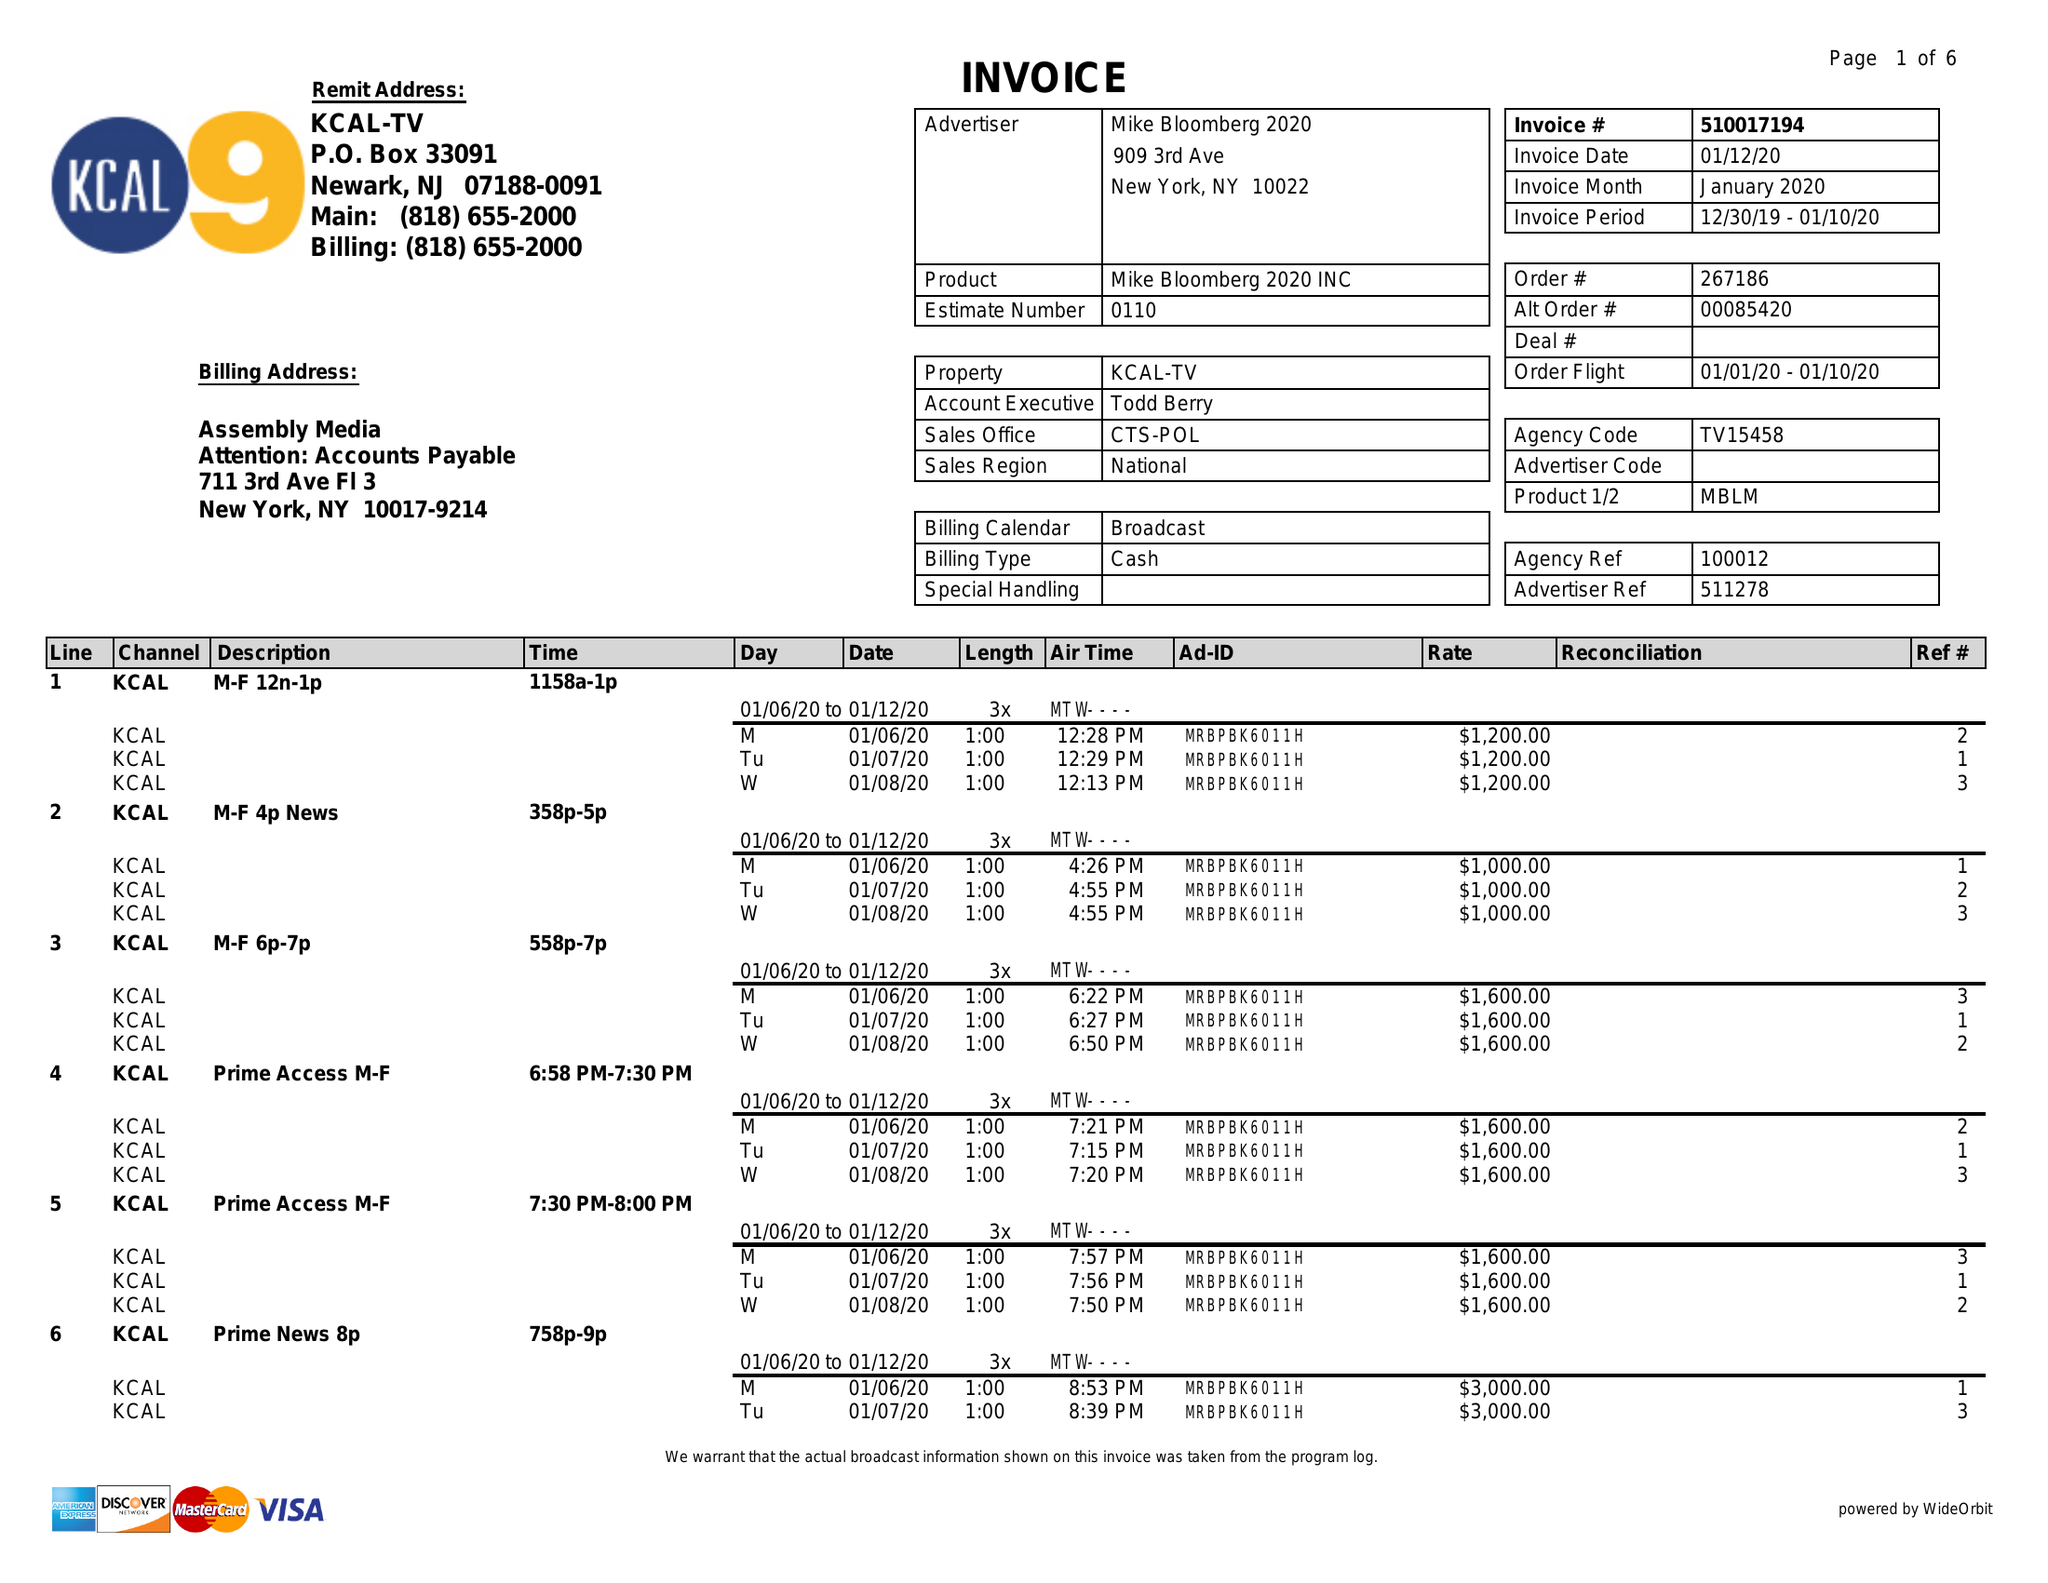What is the value for the advertiser?
Answer the question using a single word or phrase. MIKE BLOOMBERG 2020 INC 